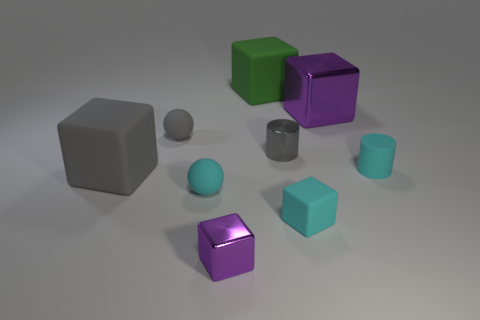How many matte things are the same color as the tiny rubber cylinder?
Your answer should be compact. 2. What is the material of the cube that is the same color as the small metal cylinder?
Provide a short and direct response. Rubber. Are there any other things that have the same shape as the big purple metal object?
Provide a succinct answer. Yes. How many objects are either small balls or small gray things?
Provide a short and direct response. 3. The cyan thing that is the same shape as the small purple shiny thing is what size?
Your answer should be very brief. Small. Is there any other thing that is the same size as the gray sphere?
Offer a terse response. Yes. What number of other things are there of the same color as the metallic cylinder?
Offer a terse response. 2. What number of blocks are tiny matte things or large purple rubber things?
Your answer should be compact. 1. What is the color of the matte block that is behind the cyan matte object to the right of the tiny rubber block?
Offer a terse response. Green. What shape is the big purple object?
Offer a terse response. Cube. 